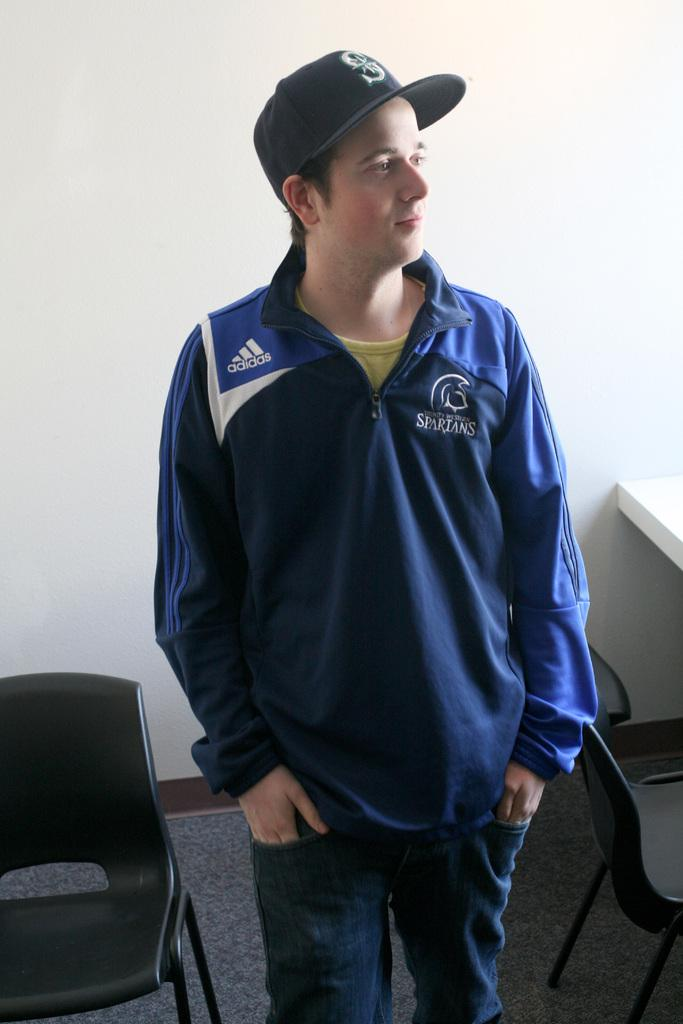<image>
Create a compact narrative representing the image presented. A man wearing a blue jacket with the word Spartans on it is looking off to the side. 